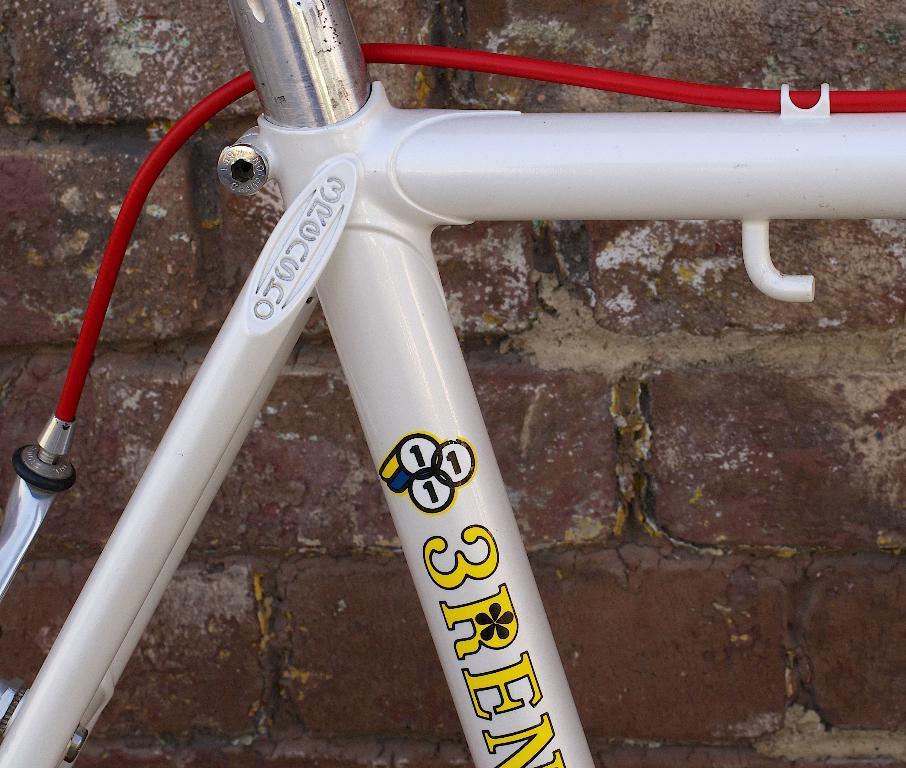How would you summarize this image in a sentence or two? In this image we can see rods and a cable. In the background there is a wall. 